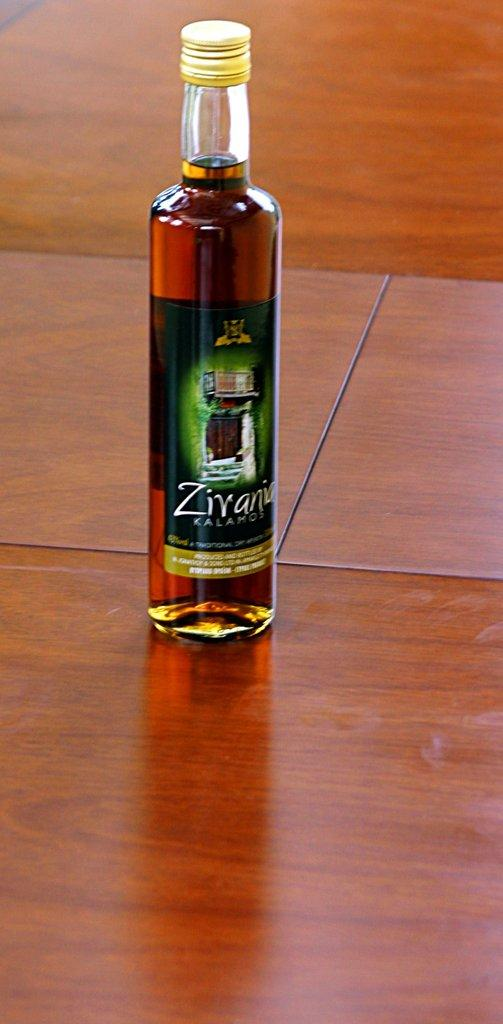Provide a one-sentence caption for the provided image. An unopened bottle of Zivania Kalamos on a green label. 